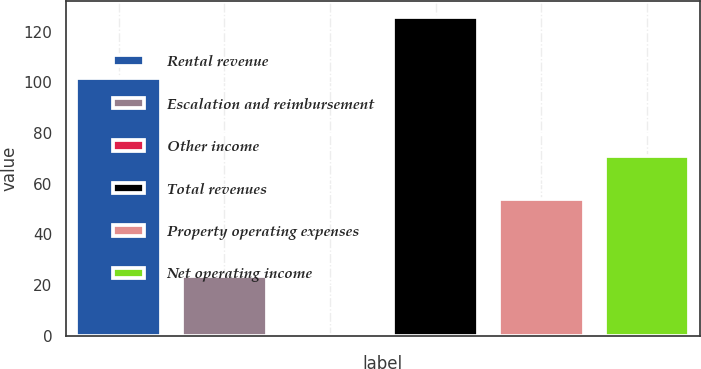Convert chart to OTSL. <chart><loc_0><loc_0><loc_500><loc_500><bar_chart><fcel>Rental revenue<fcel>Escalation and reimbursement<fcel>Other income<fcel>Total revenues<fcel>Property operating expenses<fcel>Net operating income<nl><fcel>101.9<fcel>23.5<fcel>0.3<fcel>125.7<fcel>54.1<fcel>71<nl></chart> 